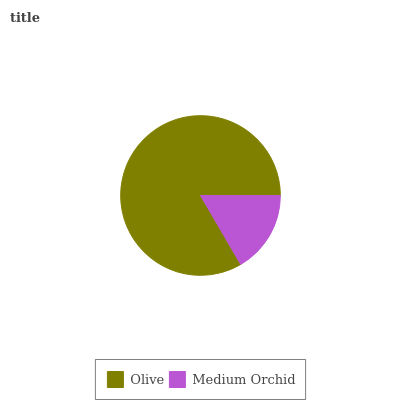Is Medium Orchid the minimum?
Answer yes or no. Yes. Is Olive the maximum?
Answer yes or no. Yes. Is Medium Orchid the maximum?
Answer yes or no. No. Is Olive greater than Medium Orchid?
Answer yes or no. Yes. Is Medium Orchid less than Olive?
Answer yes or no. Yes. Is Medium Orchid greater than Olive?
Answer yes or no. No. Is Olive less than Medium Orchid?
Answer yes or no. No. Is Olive the high median?
Answer yes or no. Yes. Is Medium Orchid the low median?
Answer yes or no. Yes. Is Medium Orchid the high median?
Answer yes or no. No. Is Olive the low median?
Answer yes or no. No. 